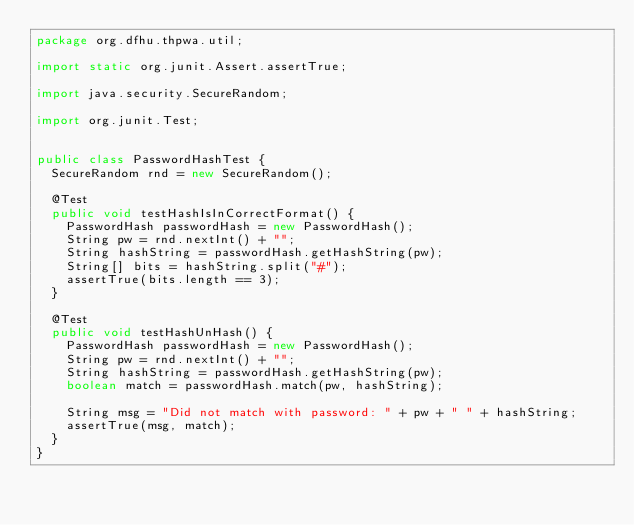Convert code to text. <code><loc_0><loc_0><loc_500><loc_500><_Java_>package org.dfhu.thpwa.util;

import static org.junit.Assert.assertTrue;

import java.security.SecureRandom;

import org.junit.Test;


public class PasswordHashTest {
  SecureRandom rnd = new SecureRandom();

  @Test
  public void testHashIsInCorrectFormat() {
    PasswordHash passwordHash = new PasswordHash();
    String pw = rnd.nextInt() + "";
    String hashString = passwordHash.getHashString(pw);
    String[] bits = hashString.split("#");
    assertTrue(bits.length == 3);
  }

  @Test
  public void testHashUnHash() {
    PasswordHash passwordHash = new PasswordHash();
    String pw = rnd.nextInt() + "";
    String hashString = passwordHash.getHashString(pw);
    boolean match = passwordHash.match(pw, hashString);

    String msg = "Did not match with password: " + pw + " " + hashString;
    assertTrue(msg, match);
  }
}</code> 